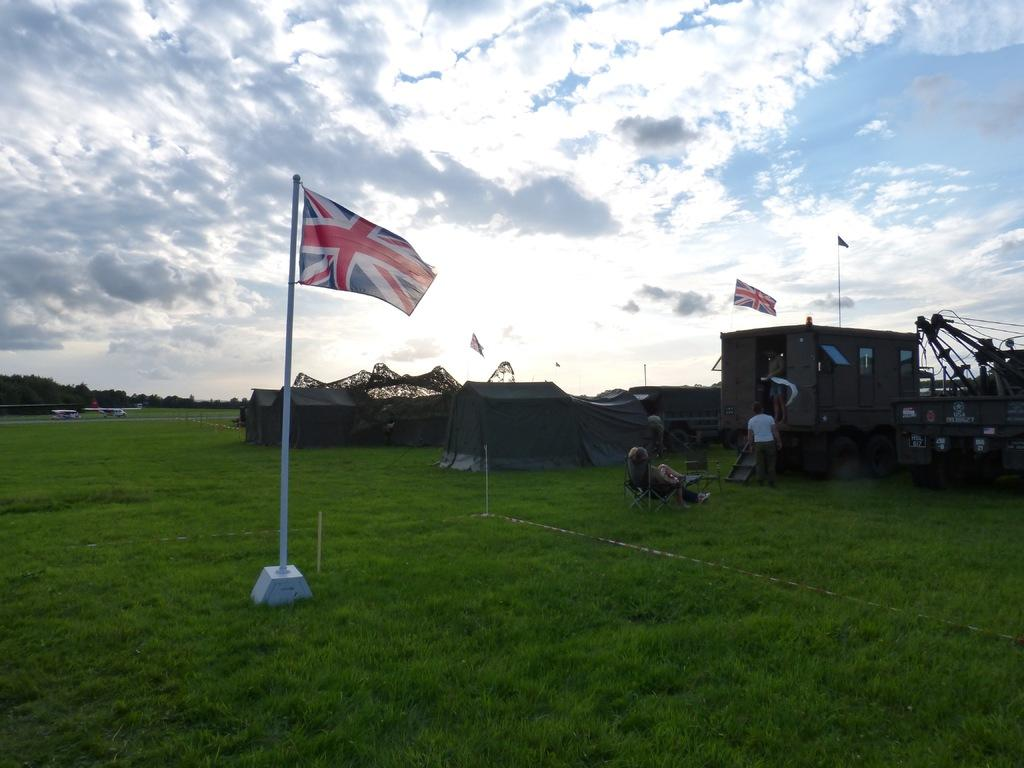Where was the image taken? The image was clicked outside. What can be seen in the middle and on the right side of the image? There is a flag in the middle and on the right side of the image. What is visible at the top of the image? There is sky visible at the top of the image. What is present at the bottom of the image? There is grass at the bottom of the image. What structure is located on the right side of the image? There is a building on the right side of the image. Can you hear the monkey coughing in the image? There is no monkey or any sound present in the image, as it is a still photograph. 